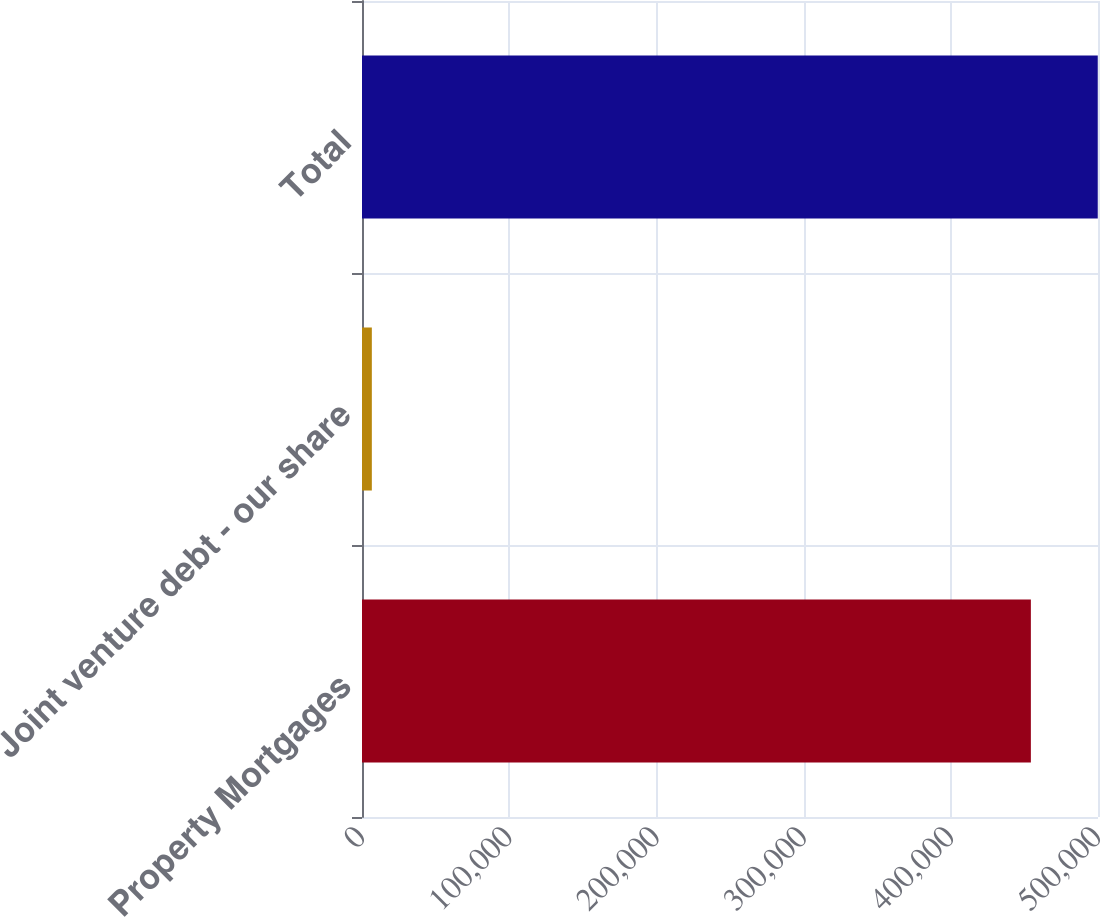Convert chart. <chart><loc_0><loc_0><loc_500><loc_500><bar_chart><fcel>Property Mortgages<fcel>Joint venture debt - our share<fcel>Total<nl><fcel>454396<fcel>6684<fcel>499836<nl></chart> 